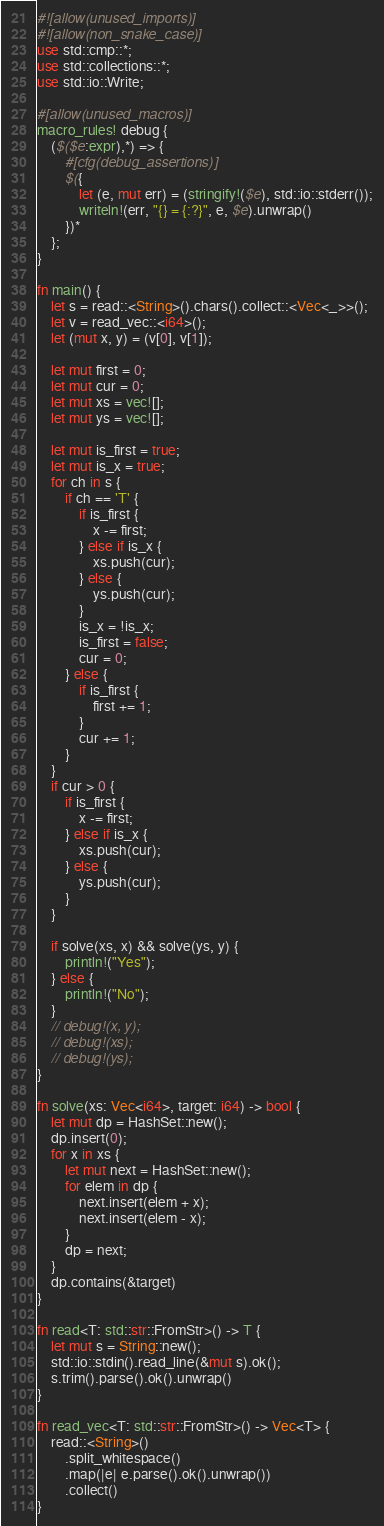Convert code to text. <code><loc_0><loc_0><loc_500><loc_500><_Rust_>#![allow(unused_imports)]
#![allow(non_snake_case)]
use std::cmp::*;
use std::collections::*;
use std::io::Write;

#[allow(unused_macros)]
macro_rules! debug {
    ($($e:expr),*) => {
        #[cfg(debug_assertions)]
        $({
            let (e, mut err) = (stringify!($e), std::io::stderr());
            writeln!(err, "{} = {:?}", e, $e).unwrap()
        })*
    };
}

fn main() {
    let s = read::<String>().chars().collect::<Vec<_>>();
    let v = read_vec::<i64>();
    let (mut x, y) = (v[0], v[1]);

    let mut first = 0;
    let mut cur = 0;
    let mut xs = vec![];
    let mut ys = vec![];

    let mut is_first = true;
    let mut is_x = true;
    for ch in s {
        if ch == 'T' {
            if is_first {
                x -= first;
            } else if is_x {
                xs.push(cur);
            } else {
                ys.push(cur);
            }
            is_x = !is_x;
            is_first = false;
            cur = 0;
        } else {
            if is_first {
                first += 1;
            }
            cur += 1;
        }
    }
    if cur > 0 {
        if is_first {
            x -= first;
        } else if is_x {
            xs.push(cur);
        } else {
            ys.push(cur);
        }
    }

    if solve(xs, x) && solve(ys, y) {
        println!("Yes");
    } else {
        println!("No");
    }
    // debug!(x, y);
    // debug!(xs);
    // debug!(ys);
}

fn solve(xs: Vec<i64>, target: i64) -> bool {
    let mut dp = HashSet::new();
    dp.insert(0);
    for x in xs {
        let mut next = HashSet::new();
        for elem in dp {
            next.insert(elem + x);
            next.insert(elem - x);
        }
        dp = next;
    }
    dp.contains(&target)
}

fn read<T: std::str::FromStr>() -> T {
    let mut s = String::new();
    std::io::stdin().read_line(&mut s).ok();
    s.trim().parse().ok().unwrap()
}

fn read_vec<T: std::str::FromStr>() -> Vec<T> {
    read::<String>()
        .split_whitespace()
        .map(|e| e.parse().ok().unwrap())
        .collect()
}
</code> 